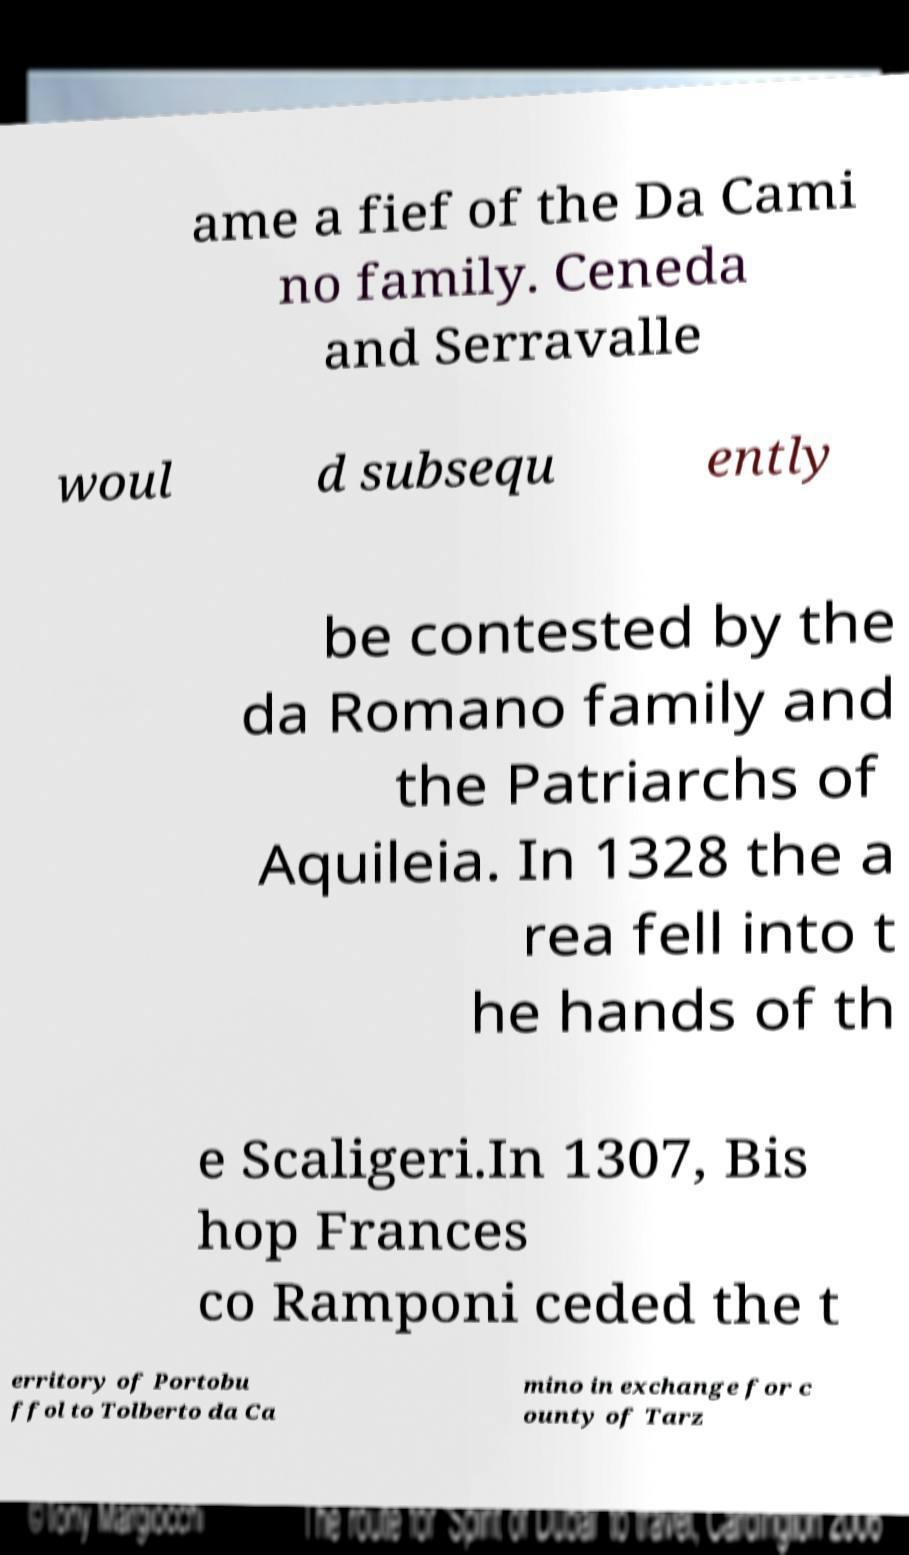There's text embedded in this image that I need extracted. Can you transcribe it verbatim? ame a fief of the Da Cami no family. Ceneda and Serravalle woul d subsequ ently be contested by the da Romano family and the Patriarchs of Aquileia. In 1328 the a rea fell into t he hands of th e Scaligeri.In 1307, Bis hop Frances co Ramponi ceded the t erritory of Portobu ffol to Tolberto da Ca mino in exchange for c ounty of Tarz 